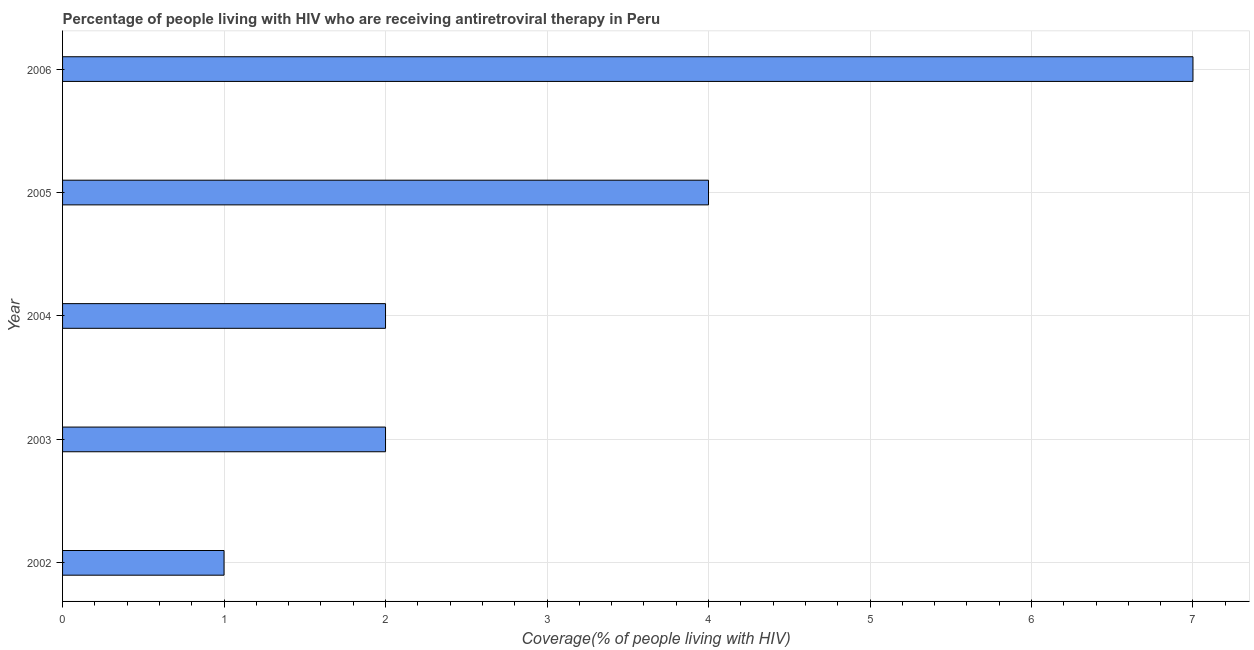What is the title of the graph?
Ensure brevity in your answer.  Percentage of people living with HIV who are receiving antiretroviral therapy in Peru. What is the label or title of the X-axis?
Ensure brevity in your answer.  Coverage(% of people living with HIV). What is the average antiretroviral therapy coverage per year?
Provide a short and direct response. 3. What is the median antiretroviral therapy coverage?
Your answer should be compact. 2. In how many years, is the antiretroviral therapy coverage greater than 5.8 %?
Make the answer very short. 1. Is the antiretroviral therapy coverage in 2002 less than that in 2003?
Your answer should be very brief. Yes. Is the sum of the antiretroviral therapy coverage in 2003 and 2006 greater than the maximum antiretroviral therapy coverage across all years?
Offer a terse response. Yes. How many bars are there?
Offer a very short reply. 5. Are all the bars in the graph horizontal?
Offer a very short reply. Yes. How many years are there in the graph?
Your answer should be compact. 5. What is the difference between two consecutive major ticks on the X-axis?
Your response must be concise. 1. What is the Coverage(% of people living with HIV) in 2004?
Your answer should be very brief. 2. What is the difference between the Coverage(% of people living with HIV) in 2002 and 2003?
Make the answer very short. -1. What is the difference between the Coverage(% of people living with HIV) in 2002 and 2004?
Make the answer very short. -1. What is the difference between the Coverage(% of people living with HIV) in 2002 and 2005?
Ensure brevity in your answer.  -3. What is the difference between the Coverage(% of people living with HIV) in 2003 and 2005?
Keep it short and to the point. -2. What is the difference between the Coverage(% of people living with HIV) in 2003 and 2006?
Keep it short and to the point. -5. What is the ratio of the Coverage(% of people living with HIV) in 2002 to that in 2004?
Your answer should be very brief. 0.5. What is the ratio of the Coverage(% of people living with HIV) in 2002 to that in 2005?
Offer a terse response. 0.25. What is the ratio of the Coverage(% of people living with HIV) in 2002 to that in 2006?
Provide a short and direct response. 0.14. What is the ratio of the Coverage(% of people living with HIV) in 2003 to that in 2004?
Provide a succinct answer. 1. What is the ratio of the Coverage(% of people living with HIV) in 2003 to that in 2006?
Your answer should be very brief. 0.29. What is the ratio of the Coverage(% of people living with HIV) in 2004 to that in 2006?
Provide a short and direct response. 0.29. What is the ratio of the Coverage(% of people living with HIV) in 2005 to that in 2006?
Make the answer very short. 0.57. 